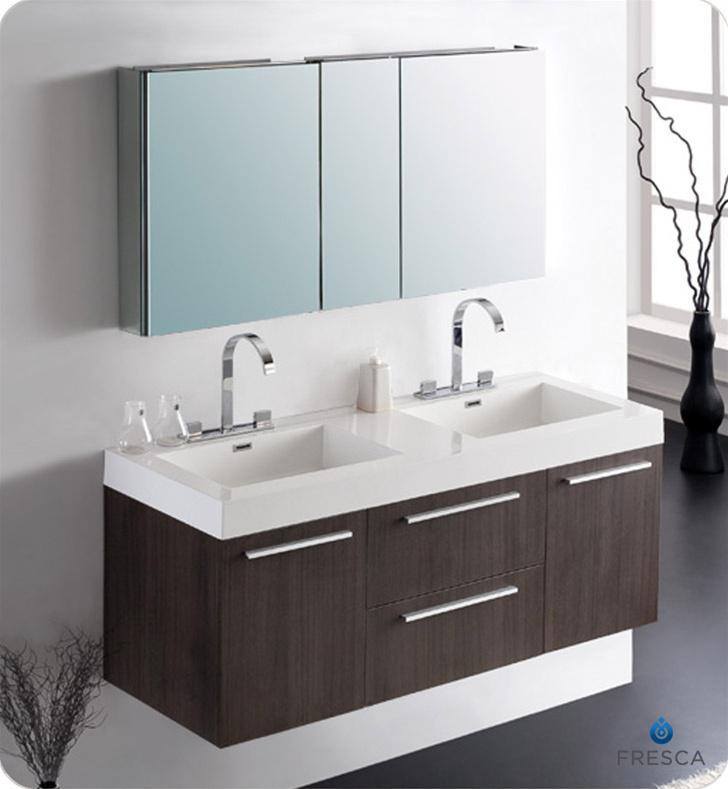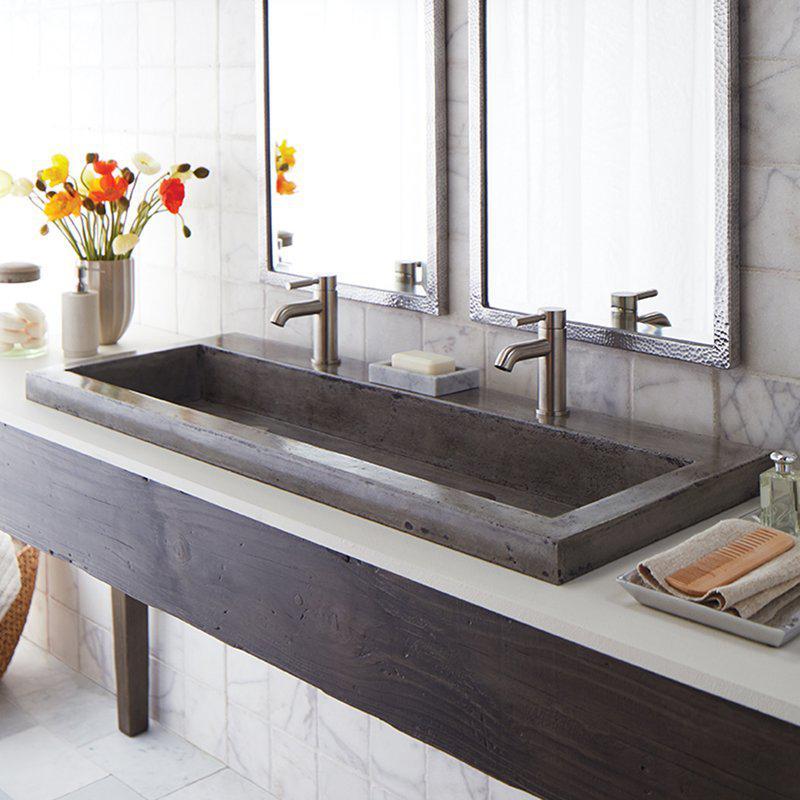The first image is the image on the left, the second image is the image on the right. For the images displayed, is the sentence "Each of the vanity sinks pictured has two faucets." factually correct? Answer yes or no. Yes. 